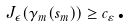Convert formula to latex. <formula><loc_0><loc_0><loc_500><loc_500>J _ { \epsilon } ( \gamma _ { m } ( s _ { m } ) ) \geq c _ { \varepsilon } \text {.}</formula> 